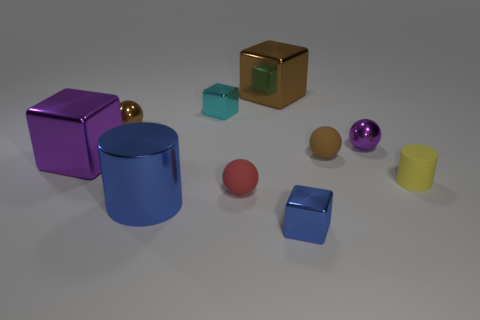Subtract 1 blocks. How many blocks are left? 3 Subtract all spheres. How many objects are left? 6 Add 4 small red rubber things. How many small red rubber things exist? 5 Subtract 0 red cylinders. How many objects are left? 10 Subtract all red objects. Subtract all blue shiny objects. How many objects are left? 7 Add 6 purple shiny things. How many purple shiny things are left? 8 